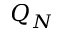<formula> <loc_0><loc_0><loc_500><loc_500>Q _ { N }</formula> 